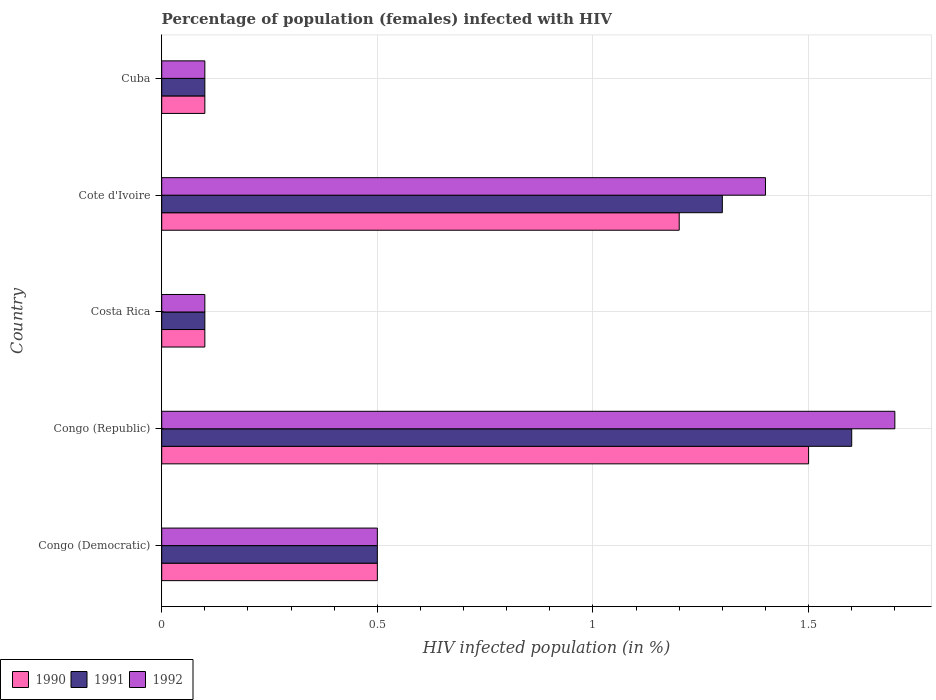How many different coloured bars are there?
Offer a very short reply. 3. Are the number of bars per tick equal to the number of legend labels?
Provide a short and direct response. Yes. Are the number of bars on each tick of the Y-axis equal?
Give a very brief answer. Yes. What is the label of the 2nd group of bars from the top?
Your answer should be compact. Cote d'Ivoire. In how many cases, is the number of bars for a given country not equal to the number of legend labels?
Your answer should be compact. 0. What is the percentage of HIV infected female population in 1990 in Cote d'Ivoire?
Your answer should be very brief. 1.2. In which country was the percentage of HIV infected female population in 1990 maximum?
Make the answer very short. Congo (Republic). What is the total percentage of HIV infected female population in 1992 in the graph?
Offer a very short reply. 3.8. What is the difference between the percentage of HIV infected female population in 1992 in Congo (Republic) and that in Cuba?
Make the answer very short. 1.6. What is the difference between the percentage of HIV infected female population in 1990 in Congo (Republic) and the percentage of HIV infected female population in 1992 in Cote d'Ivoire?
Give a very brief answer. 0.1. What is the average percentage of HIV infected female population in 1991 per country?
Provide a short and direct response. 0.72. What is the difference between the percentage of HIV infected female population in 1991 and percentage of HIV infected female population in 1992 in Congo (Democratic)?
Your response must be concise. 0. What is the ratio of the percentage of HIV infected female population in 1990 in Congo (Democratic) to that in Cote d'Ivoire?
Offer a very short reply. 0.42. Is the difference between the percentage of HIV infected female population in 1991 in Congo (Republic) and Cuba greater than the difference between the percentage of HIV infected female population in 1992 in Congo (Republic) and Cuba?
Keep it short and to the point. No. What is the difference between the highest and the second highest percentage of HIV infected female population in 1990?
Your answer should be compact. 0.3. What is the difference between the highest and the lowest percentage of HIV infected female population in 1991?
Your answer should be compact. 1.5. In how many countries, is the percentage of HIV infected female population in 1992 greater than the average percentage of HIV infected female population in 1992 taken over all countries?
Provide a succinct answer. 2. What does the 3rd bar from the bottom in Congo (Republic) represents?
Your response must be concise. 1992. How many bars are there?
Ensure brevity in your answer.  15. Are all the bars in the graph horizontal?
Ensure brevity in your answer.  Yes. How many countries are there in the graph?
Ensure brevity in your answer.  5. What is the difference between two consecutive major ticks on the X-axis?
Keep it short and to the point. 0.5. Does the graph contain any zero values?
Provide a succinct answer. No. Where does the legend appear in the graph?
Your answer should be compact. Bottom left. What is the title of the graph?
Give a very brief answer. Percentage of population (females) infected with HIV. What is the label or title of the X-axis?
Your response must be concise. HIV infected population (in %). What is the HIV infected population (in %) of 1991 in Congo (Democratic)?
Your answer should be compact. 0.5. What is the HIV infected population (in %) in 1991 in Congo (Republic)?
Make the answer very short. 1.6. What is the HIV infected population (in %) of 1992 in Costa Rica?
Your answer should be very brief. 0.1. What is the HIV infected population (in %) of 1990 in Cote d'Ivoire?
Give a very brief answer. 1.2. What is the HIV infected population (in %) of 1991 in Cote d'Ivoire?
Your answer should be compact. 1.3. What is the HIV infected population (in %) of 1991 in Cuba?
Offer a terse response. 0.1. What is the HIV infected population (in %) of 1992 in Cuba?
Ensure brevity in your answer.  0.1. Across all countries, what is the minimum HIV infected population (in %) in 1990?
Your response must be concise. 0.1. Across all countries, what is the minimum HIV infected population (in %) of 1991?
Your response must be concise. 0.1. Across all countries, what is the minimum HIV infected population (in %) in 1992?
Offer a very short reply. 0.1. What is the total HIV infected population (in %) in 1990 in the graph?
Your answer should be compact. 3.4. What is the total HIV infected population (in %) in 1991 in the graph?
Offer a very short reply. 3.6. What is the difference between the HIV infected population (in %) in 1990 in Congo (Democratic) and that in Congo (Republic)?
Your response must be concise. -1. What is the difference between the HIV infected population (in %) of 1991 in Congo (Democratic) and that in Congo (Republic)?
Ensure brevity in your answer.  -1.1. What is the difference between the HIV infected population (in %) in 1992 in Congo (Democratic) and that in Congo (Republic)?
Make the answer very short. -1.2. What is the difference between the HIV infected population (in %) in 1990 in Congo (Democratic) and that in Costa Rica?
Your response must be concise. 0.4. What is the difference between the HIV infected population (in %) in 1991 in Congo (Democratic) and that in Costa Rica?
Offer a very short reply. 0.4. What is the difference between the HIV infected population (in %) in 1992 in Congo (Democratic) and that in Costa Rica?
Keep it short and to the point. 0.4. What is the difference between the HIV infected population (in %) in 1990 in Congo (Democratic) and that in Cote d'Ivoire?
Ensure brevity in your answer.  -0.7. What is the difference between the HIV infected population (in %) of 1992 in Congo (Democratic) and that in Cote d'Ivoire?
Provide a short and direct response. -0.9. What is the difference between the HIV infected population (in %) of 1992 in Congo (Democratic) and that in Cuba?
Your response must be concise. 0.4. What is the difference between the HIV infected population (in %) in 1992 in Congo (Republic) and that in Cote d'Ivoire?
Your answer should be very brief. 0.3. What is the difference between the HIV infected population (in %) in 1992 in Congo (Republic) and that in Cuba?
Provide a short and direct response. 1.6. What is the difference between the HIV infected population (in %) of 1992 in Costa Rica and that in Cote d'Ivoire?
Make the answer very short. -1.3. What is the difference between the HIV infected population (in %) of 1991 in Costa Rica and that in Cuba?
Your answer should be very brief. 0. What is the difference between the HIV infected population (in %) in 1992 in Costa Rica and that in Cuba?
Ensure brevity in your answer.  0. What is the difference between the HIV infected population (in %) in 1991 in Cote d'Ivoire and that in Cuba?
Make the answer very short. 1.2. What is the difference between the HIV infected population (in %) in 1990 in Congo (Democratic) and the HIV infected population (in %) in 1991 in Congo (Republic)?
Ensure brevity in your answer.  -1.1. What is the difference between the HIV infected population (in %) in 1990 in Congo (Democratic) and the HIV infected population (in %) in 1992 in Congo (Republic)?
Offer a very short reply. -1.2. What is the difference between the HIV infected population (in %) of 1991 in Congo (Democratic) and the HIV infected population (in %) of 1992 in Congo (Republic)?
Your response must be concise. -1.2. What is the difference between the HIV infected population (in %) of 1990 in Congo (Democratic) and the HIV infected population (in %) of 1992 in Costa Rica?
Your answer should be compact. 0.4. What is the difference between the HIV infected population (in %) in 1990 in Congo (Democratic) and the HIV infected population (in %) in 1991 in Cote d'Ivoire?
Offer a very short reply. -0.8. What is the difference between the HIV infected population (in %) of 1990 in Congo (Democratic) and the HIV infected population (in %) of 1992 in Cote d'Ivoire?
Provide a succinct answer. -0.9. What is the difference between the HIV infected population (in %) in 1991 in Congo (Democratic) and the HIV infected population (in %) in 1992 in Cote d'Ivoire?
Offer a terse response. -0.9. What is the difference between the HIV infected population (in %) of 1990 in Congo (Democratic) and the HIV infected population (in %) of 1991 in Cuba?
Your response must be concise. 0.4. What is the difference between the HIV infected population (in %) of 1991 in Congo (Democratic) and the HIV infected population (in %) of 1992 in Cuba?
Provide a short and direct response. 0.4. What is the difference between the HIV infected population (in %) in 1990 in Congo (Republic) and the HIV infected population (in %) in 1991 in Costa Rica?
Offer a terse response. 1.4. What is the difference between the HIV infected population (in %) of 1991 in Congo (Republic) and the HIV infected population (in %) of 1992 in Costa Rica?
Provide a short and direct response. 1.5. What is the difference between the HIV infected population (in %) in 1990 in Congo (Republic) and the HIV infected population (in %) in 1991 in Cote d'Ivoire?
Keep it short and to the point. 0.2. What is the difference between the HIV infected population (in %) of 1990 in Congo (Republic) and the HIV infected population (in %) of 1992 in Cuba?
Your answer should be very brief. 1.4. What is the difference between the HIV infected population (in %) of 1991 in Congo (Republic) and the HIV infected population (in %) of 1992 in Cuba?
Offer a terse response. 1.5. What is the difference between the HIV infected population (in %) of 1990 in Costa Rica and the HIV infected population (in %) of 1992 in Cote d'Ivoire?
Provide a short and direct response. -1.3. What is the difference between the HIV infected population (in %) in 1990 in Costa Rica and the HIV infected population (in %) in 1992 in Cuba?
Give a very brief answer. 0. What is the difference between the HIV infected population (in %) of 1990 in Cote d'Ivoire and the HIV infected population (in %) of 1991 in Cuba?
Keep it short and to the point. 1.1. What is the average HIV infected population (in %) in 1990 per country?
Ensure brevity in your answer.  0.68. What is the average HIV infected population (in %) of 1991 per country?
Keep it short and to the point. 0.72. What is the average HIV infected population (in %) of 1992 per country?
Provide a succinct answer. 0.76. What is the difference between the HIV infected population (in %) in 1990 and HIV infected population (in %) in 1992 in Congo (Democratic)?
Your answer should be compact. 0. What is the difference between the HIV infected population (in %) in 1991 and HIV infected population (in %) in 1992 in Congo (Democratic)?
Make the answer very short. 0. What is the difference between the HIV infected population (in %) of 1990 and HIV infected population (in %) of 1991 in Costa Rica?
Keep it short and to the point. 0. What is the difference between the HIV infected population (in %) in 1990 and HIV infected population (in %) in 1992 in Costa Rica?
Offer a very short reply. 0. What is the difference between the HIV infected population (in %) in 1991 and HIV infected population (in %) in 1992 in Costa Rica?
Provide a short and direct response. 0. What is the difference between the HIV infected population (in %) in 1990 and HIV infected population (in %) in 1991 in Cote d'Ivoire?
Give a very brief answer. -0.1. What is the difference between the HIV infected population (in %) of 1991 and HIV infected population (in %) of 1992 in Cote d'Ivoire?
Keep it short and to the point. -0.1. What is the difference between the HIV infected population (in %) in 1990 and HIV infected population (in %) in 1991 in Cuba?
Your answer should be compact. 0. What is the difference between the HIV infected population (in %) of 1990 and HIV infected population (in %) of 1992 in Cuba?
Make the answer very short. 0. What is the ratio of the HIV infected population (in %) in 1990 in Congo (Democratic) to that in Congo (Republic)?
Your answer should be compact. 0.33. What is the ratio of the HIV infected population (in %) of 1991 in Congo (Democratic) to that in Congo (Republic)?
Your answer should be very brief. 0.31. What is the ratio of the HIV infected population (in %) of 1992 in Congo (Democratic) to that in Congo (Republic)?
Give a very brief answer. 0.29. What is the ratio of the HIV infected population (in %) in 1990 in Congo (Democratic) to that in Cote d'Ivoire?
Offer a very short reply. 0.42. What is the ratio of the HIV infected population (in %) in 1991 in Congo (Democratic) to that in Cote d'Ivoire?
Provide a short and direct response. 0.38. What is the ratio of the HIV infected population (in %) in 1992 in Congo (Democratic) to that in Cote d'Ivoire?
Make the answer very short. 0.36. What is the ratio of the HIV infected population (in %) of 1992 in Congo (Democratic) to that in Cuba?
Offer a terse response. 5. What is the ratio of the HIV infected population (in %) in 1992 in Congo (Republic) to that in Costa Rica?
Your response must be concise. 17. What is the ratio of the HIV infected population (in %) in 1991 in Congo (Republic) to that in Cote d'Ivoire?
Your response must be concise. 1.23. What is the ratio of the HIV infected population (in %) of 1992 in Congo (Republic) to that in Cote d'Ivoire?
Your answer should be compact. 1.21. What is the ratio of the HIV infected population (in %) of 1991 in Congo (Republic) to that in Cuba?
Give a very brief answer. 16. What is the ratio of the HIV infected population (in %) of 1992 in Congo (Republic) to that in Cuba?
Ensure brevity in your answer.  17. What is the ratio of the HIV infected population (in %) in 1990 in Costa Rica to that in Cote d'Ivoire?
Offer a terse response. 0.08. What is the ratio of the HIV infected population (in %) of 1991 in Costa Rica to that in Cote d'Ivoire?
Offer a terse response. 0.08. What is the ratio of the HIV infected population (in %) in 1992 in Costa Rica to that in Cote d'Ivoire?
Your response must be concise. 0.07. What is the ratio of the HIV infected population (in %) in 1990 in Costa Rica to that in Cuba?
Give a very brief answer. 1. What is the ratio of the HIV infected population (in %) of 1991 in Costa Rica to that in Cuba?
Make the answer very short. 1. What is the ratio of the HIV infected population (in %) in 1992 in Costa Rica to that in Cuba?
Give a very brief answer. 1. What is the ratio of the HIV infected population (in %) of 1992 in Cote d'Ivoire to that in Cuba?
Make the answer very short. 14. What is the difference between the highest and the second highest HIV infected population (in %) in 1990?
Make the answer very short. 0.3. What is the difference between the highest and the second highest HIV infected population (in %) in 1991?
Keep it short and to the point. 0.3. What is the difference between the highest and the second highest HIV infected population (in %) of 1992?
Ensure brevity in your answer.  0.3. What is the difference between the highest and the lowest HIV infected population (in %) of 1991?
Keep it short and to the point. 1.5. 